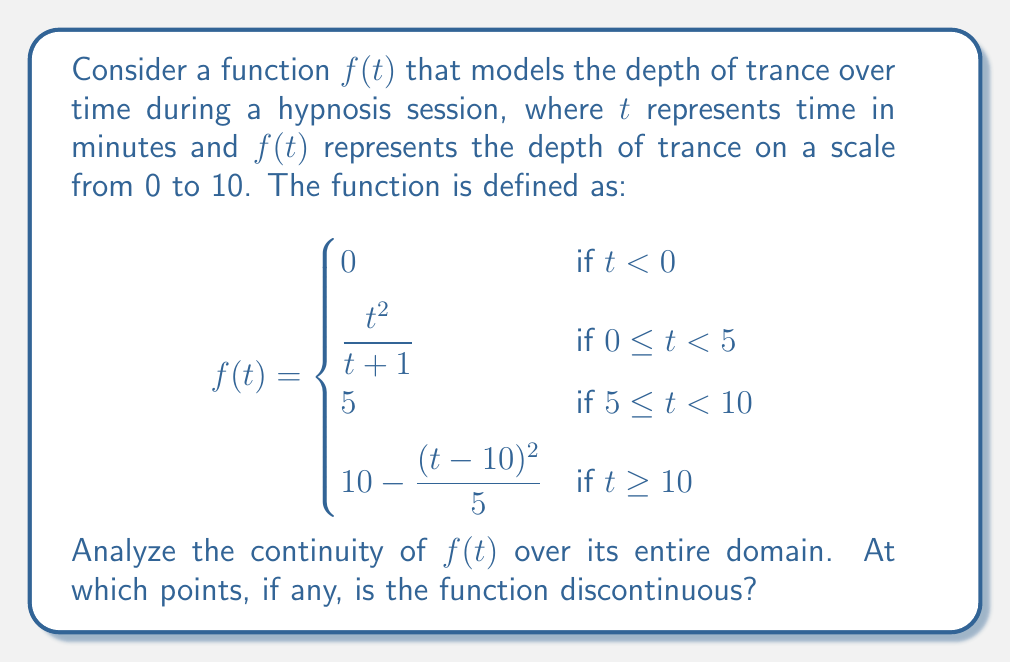Show me your answer to this math problem. To analyze the continuity of $f(t)$, we need to check for continuity at each piecewise boundary and ensure the function is continuous within each piece.

1. Continuity within each piece:
   - For $t < 0$, $f(t) = 0$ is constant and therefore continuous.
   - For $0 \leq t < 5$, $f(t) = \frac{t^2}{t+1}$ is a rational function with a denominator that's never zero, so it's continuous.
   - For $5 \leq t < 10$, $f(t) = 5$ is constant and therefore continuous.
   - For $t \geq 10$, $f(t) = 10 - \frac{(t-10)^2}{5}$ is a polynomial function and therefore continuous.

2. Continuity at $t = 0$:
   Left limit: $\lim_{t \to 0^-} f(t) = 0$
   Right limit: $\lim_{t \to 0^+} f(t) = \lim_{t \to 0^+} \frac{t^2}{t+1} = 0$
   Function value: $f(0) = \frac{0^2}{0+1} = 0$
   All three values are equal, so $f(t)$ is continuous at $t = 0$.

3. Continuity at $t = 5$:
   Left limit: $\lim_{t \to 5^-} f(t) = \lim_{t \to 5^-} \frac{t^2}{t+1} = \frac{25}{6} \approx 4.17$
   Right limit: $\lim_{t \to 5^+} f(t) = 5$
   Function value: $f(5) = 5$
   The left limit doesn't equal the right limit and function value, so $f(t)$ is discontinuous at $t = 5$.

4. Continuity at $t = 10$:
   Left limit: $\lim_{t \to 10^-} f(t) = 5$
   Right limit: $\lim_{t \to 10^+} f(t) = \lim_{t \to 10^+} (10 - \frac{(t-10)^2}{5}) = 10$
   Function value: $f(10) = 10 - \frac{(10-10)^2}{5} = 10$
   The left limit doesn't equal the right limit and function value, so $f(t)$ is discontinuous at $t = 10$.

Therefore, the function $f(t)$ is discontinuous at $t = 5$ and $t = 10$.
Answer: The function $f(t)$ is discontinuous at $t = 5$ and $t = 10$. 